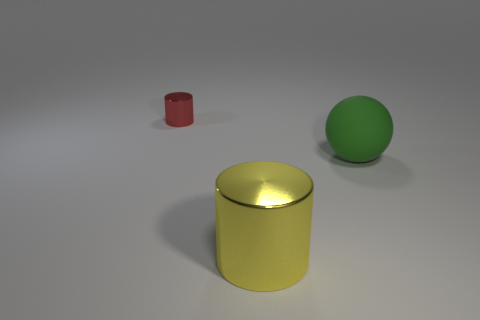Is there anything else that has the same size as the red thing?
Offer a very short reply. No. The green ball is what size?
Give a very brief answer. Large. Is the matte object the same size as the red shiny object?
Offer a terse response. No. What color is the thing that is both behind the large metal thing and on the left side of the green rubber sphere?
Your response must be concise. Red. How many other big cylinders are made of the same material as the large cylinder?
Offer a terse response. 0. How many big brown rubber cylinders are there?
Provide a succinct answer. 0. There is a red cylinder; is its size the same as the metal cylinder that is in front of the big green matte object?
Your answer should be very brief. No. There is a large object on the right side of the object in front of the ball; what is its material?
Make the answer very short. Rubber. There is a metallic cylinder behind the big yellow shiny object on the right side of the shiny thing behind the large metal cylinder; what is its size?
Your response must be concise. Small. There is a small thing; does it have the same shape as the shiny thing that is in front of the red metallic thing?
Ensure brevity in your answer.  Yes. 